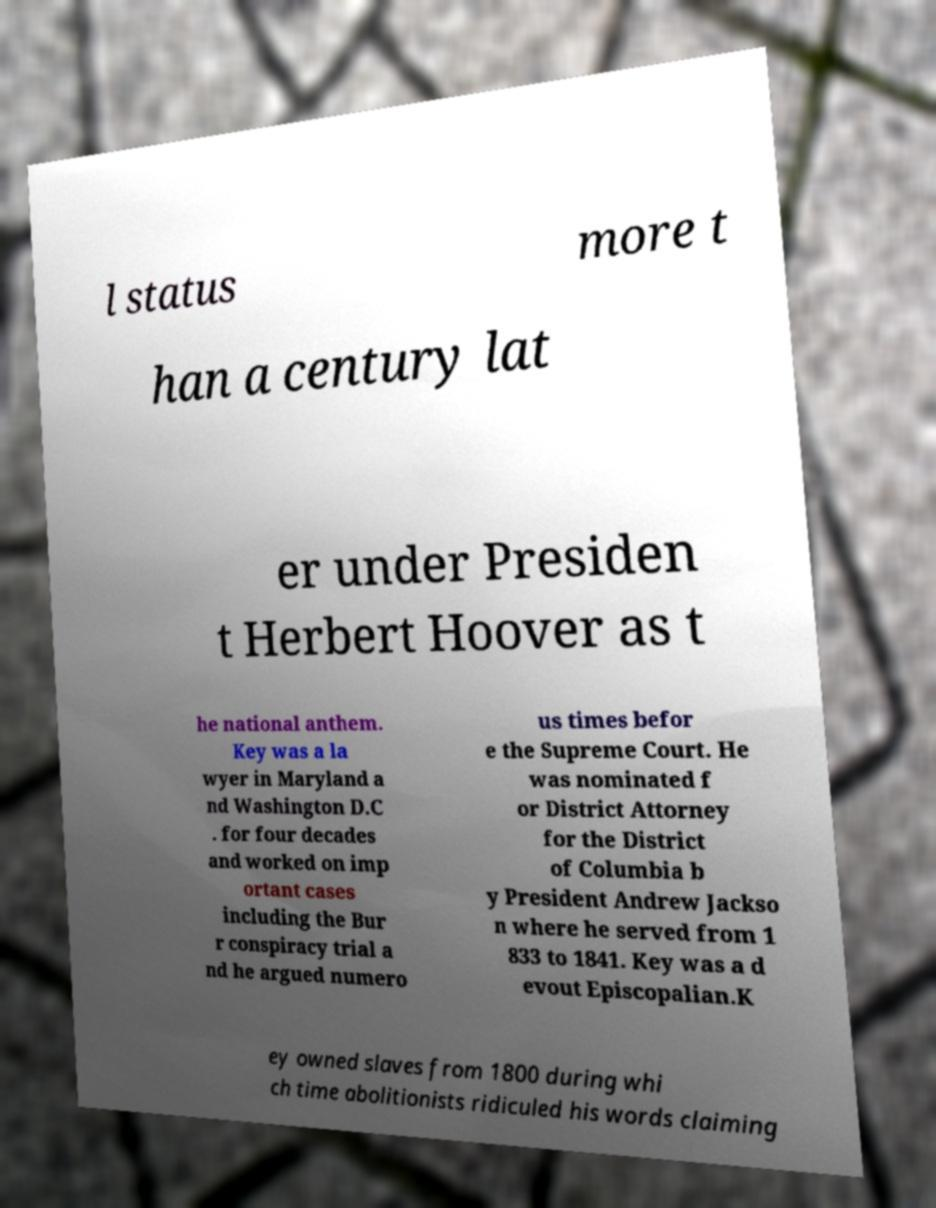Can you read and provide the text displayed in the image?This photo seems to have some interesting text. Can you extract and type it out for me? l status more t han a century lat er under Presiden t Herbert Hoover as t he national anthem. Key was a la wyer in Maryland a nd Washington D.C . for four decades and worked on imp ortant cases including the Bur r conspiracy trial a nd he argued numero us times befor e the Supreme Court. He was nominated f or District Attorney for the District of Columbia b y President Andrew Jackso n where he served from 1 833 to 1841. Key was a d evout Episcopalian.K ey owned slaves from 1800 during whi ch time abolitionists ridiculed his words claiming 